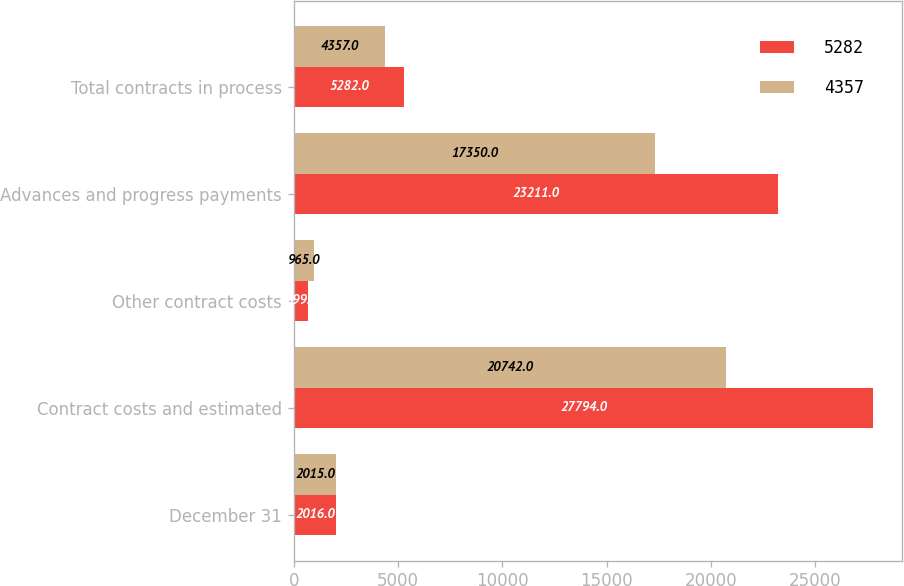Convert chart to OTSL. <chart><loc_0><loc_0><loc_500><loc_500><stacked_bar_chart><ecel><fcel>December 31<fcel>Contract costs and estimated<fcel>Other contract costs<fcel>Advances and progress payments<fcel>Total contracts in process<nl><fcel>5282<fcel>2016<fcel>27794<fcel>699<fcel>23211<fcel>5282<nl><fcel>4357<fcel>2015<fcel>20742<fcel>965<fcel>17350<fcel>4357<nl></chart> 